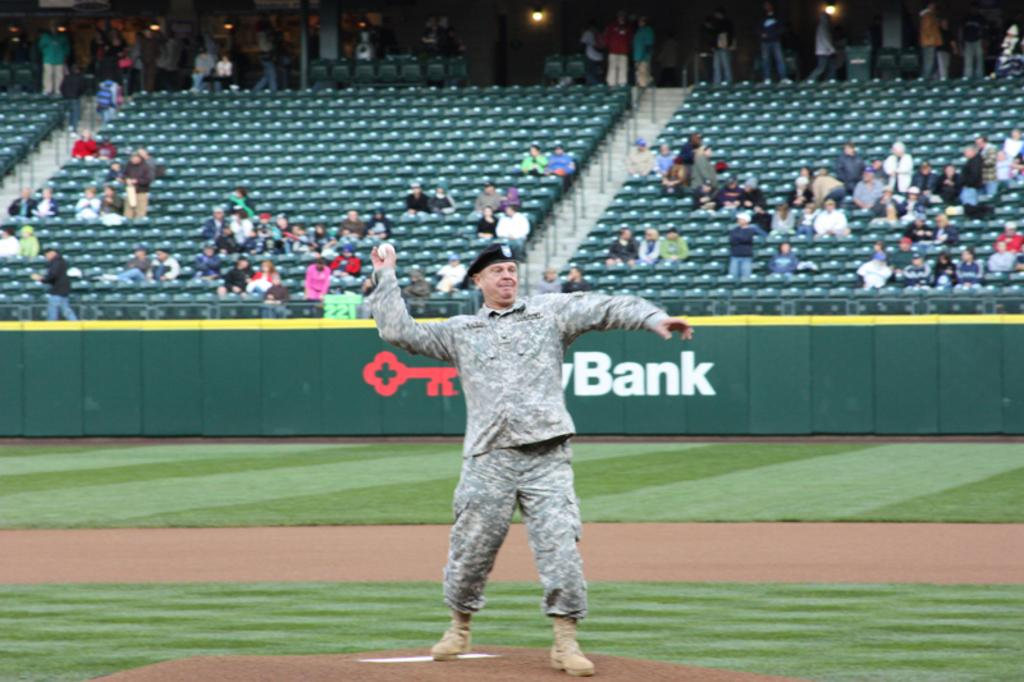<image>
Give a short and clear explanation of the subsequent image. US Army Soldier throwing the first pitch at a baseball game, with a key bank logo in the background. 